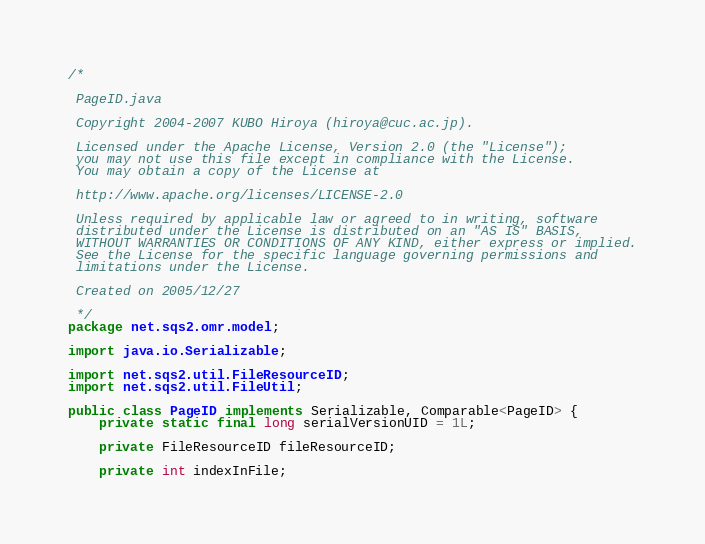<code> <loc_0><loc_0><loc_500><loc_500><_Java_>/*

 PageID.java

 Copyright 2004-2007 KUBO Hiroya (hiroya@cuc.ac.jp).

 Licensed under the Apache License, Version 2.0 (the "License");
 you may not use this file except in compliance with the License.
 You may obtain a copy of the License at

 http://www.apache.org/licenses/LICENSE-2.0

 Unless required by applicable law or agreed to in writing, software
 distributed under the License is distributed on an "AS IS" BASIS,
 WITHOUT WARRANTIES OR CONDITIONS OF ANY KIND, either express or implied.
 See the License for the specific language governing permissions and
 limitations under the License.

 Created on 2005/12/27

 */
package net.sqs2.omr.model;

import java.io.Serializable;

import net.sqs2.util.FileResourceID;
import net.sqs2.util.FileUtil;

public class PageID implements Serializable, Comparable<PageID> {
	private static final long serialVersionUID = 1L;

	private FileResourceID fileResourceID;

	private int indexInFile;</code> 